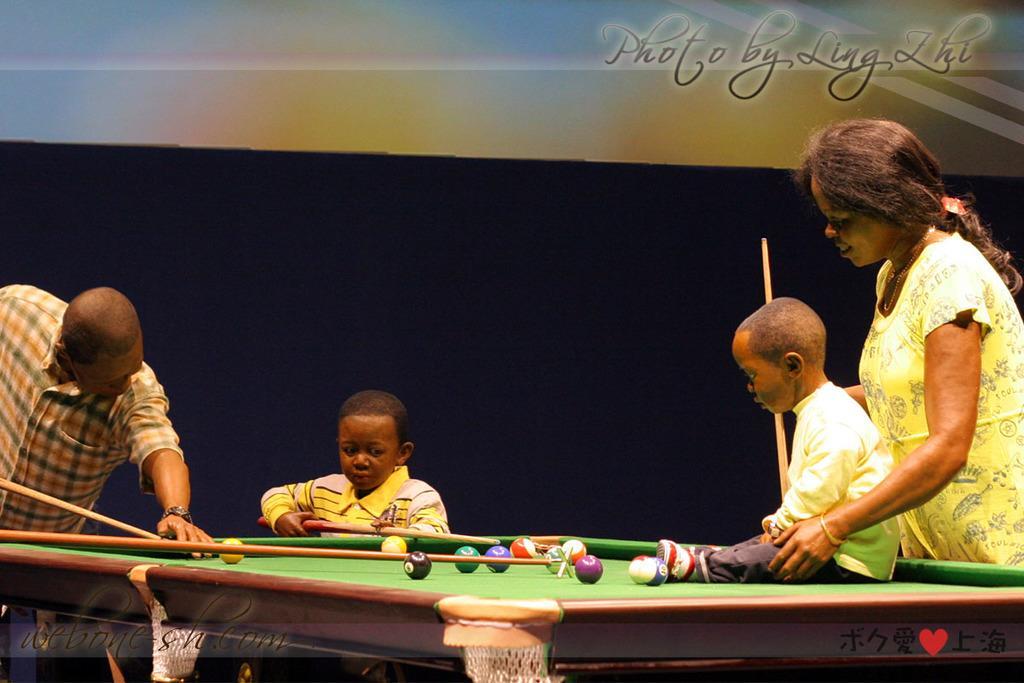Could you give a brief overview of what you see in this image? In this image, we can see people playing pool at billiard table. There is a kid in the bottom right of the image sitting on billiard table. There is a text in the top right of the image. 